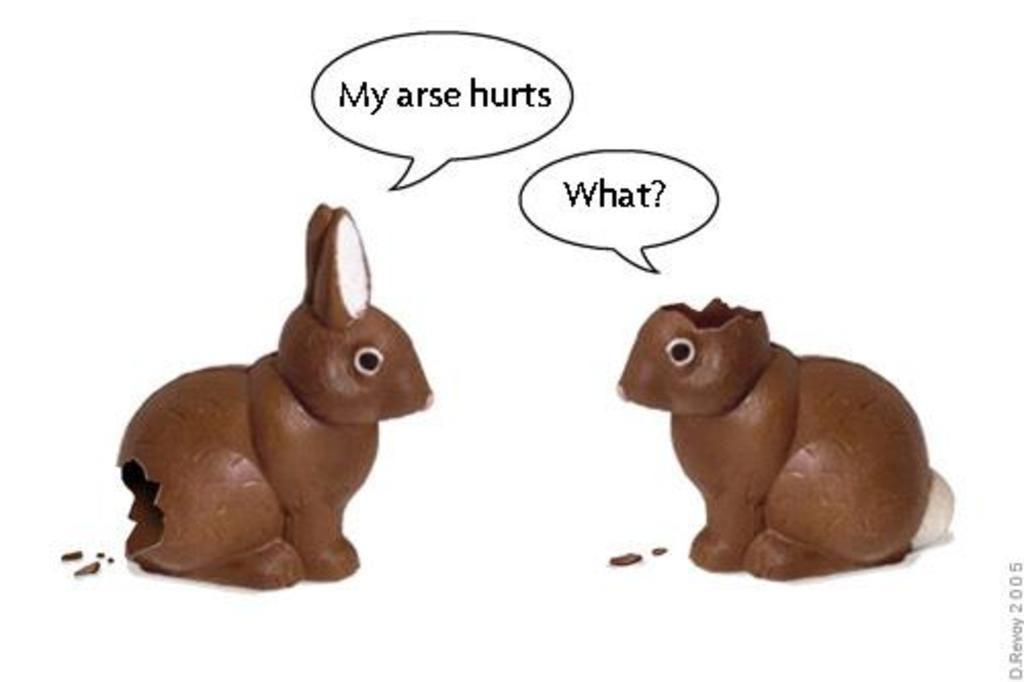What type of dolls are featured in the image? There are animated rat dolls in the image. What can be seen above the rat dolls? There are thoughts written above the rat dolls. What type of worm can be seen crawling on the scarecrow in the image? There is no worm or scarecrow present in the image; it features animated rat dolls with thoughts written above them. 